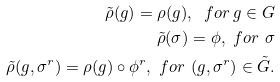<formula> <loc_0><loc_0><loc_500><loc_500>\tilde { \rho } ( g ) = \rho ( g ) , \ f o r \, g \in G \\ \tilde { \rho } ( \sigma ) = \phi , \ f o r \ \sigma \\ \tilde { \rho } ( g , \sigma ^ { r } ) = \rho ( g ) \circ \phi ^ { r } , \ f o r \ ( g , \sigma ^ { r } ) \in \tilde { G } .</formula> 